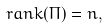<formula> <loc_0><loc_0><loc_500><loc_500>\ r a n k ( \Pi ) = n ,</formula> 